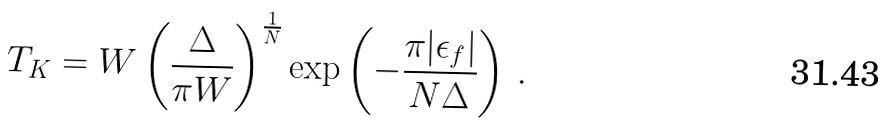<formula> <loc_0><loc_0><loc_500><loc_500>T _ { K } = W \left ( \frac { \Delta } { \pi W } \right ) ^ { \frac { 1 } { N } } \exp \left ( - \frac { \pi | \epsilon _ { f } | } { N \Delta } \right ) \, .</formula> 